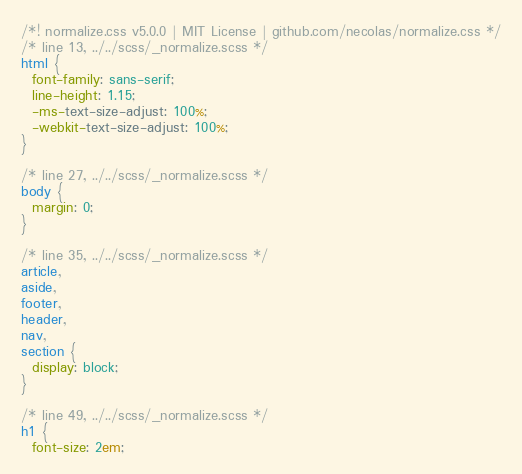<code> <loc_0><loc_0><loc_500><loc_500><_CSS_>/*! normalize.css v5.0.0 | MIT License | github.com/necolas/normalize.css */
/* line 13, ../../scss/_normalize.scss */
html {
  font-family: sans-serif;
  line-height: 1.15;
  -ms-text-size-adjust: 100%;
  -webkit-text-size-adjust: 100%;
}

/* line 27, ../../scss/_normalize.scss */
body {
  margin: 0;
}

/* line 35, ../../scss/_normalize.scss */
article,
aside,
footer,
header,
nav,
section {
  display: block;
}

/* line 49, ../../scss/_normalize.scss */
h1 {
  font-size: 2em;</code> 